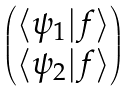Convert formula to latex. <formula><loc_0><loc_0><loc_500><loc_500>\begin{pmatrix} \langle \psi _ { 1 } | f \rangle \\ \langle \psi _ { 2 } | f \rangle \end{pmatrix}</formula> 